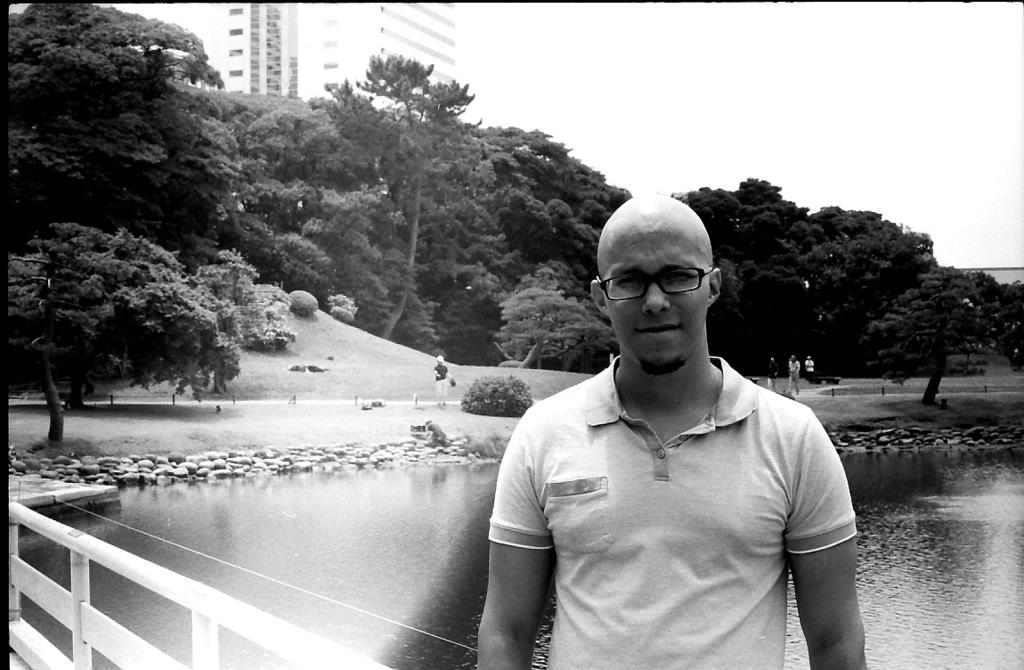What is the person in the image standing in front of? The person is standing in front of the fencing. What can be seen behind the fencing? There is a lake behind the fencing. What type of vegetation is around the lake? There are trees around the lake. Are there any other people in the image? Yes, there are people around the lake. What structures are visible around the lake? There are buildings around the lake. What type of liquid is being poured out of the tent in the image? There is no tent or liquid present in the image. 